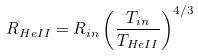Convert formula to latex. <formula><loc_0><loc_0><loc_500><loc_500>R _ { H e I I } = R _ { i n } \left ( \frac { T _ { i n } } { T _ { H e I I } } \right ) ^ { 4 / 3 }</formula> 